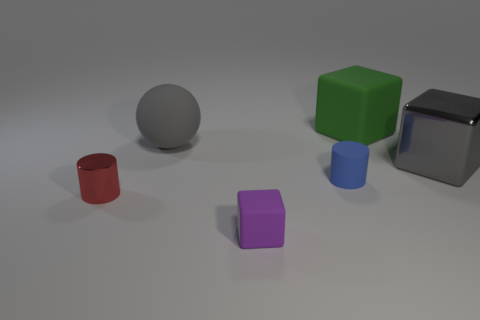What is the color of the cube that is in front of the big matte ball and left of the large gray block?
Make the answer very short. Purple. Are there any tiny cylinders that have the same color as the big metal cube?
Your answer should be compact. No. What is the color of the block that is behind the sphere?
Make the answer very short. Green. There is a big matte thing that is on the left side of the green block; is there a large gray sphere to the right of it?
Ensure brevity in your answer.  No. There is a large ball; is it the same color as the cylinder that is to the right of the gray rubber thing?
Ensure brevity in your answer.  No. Is there a tiny red thing made of the same material as the green block?
Your response must be concise. No. How many purple objects are there?
Give a very brief answer. 1. There is a gray thing that is on the right side of the gray thing that is left of the big green rubber block; what is it made of?
Offer a very short reply. Metal. There is a cylinder that is made of the same material as the big green cube; what color is it?
Give a very brief answer. Blue. The object that is the same color as the large ball is what shape?
Your response must be concise. Cube. 